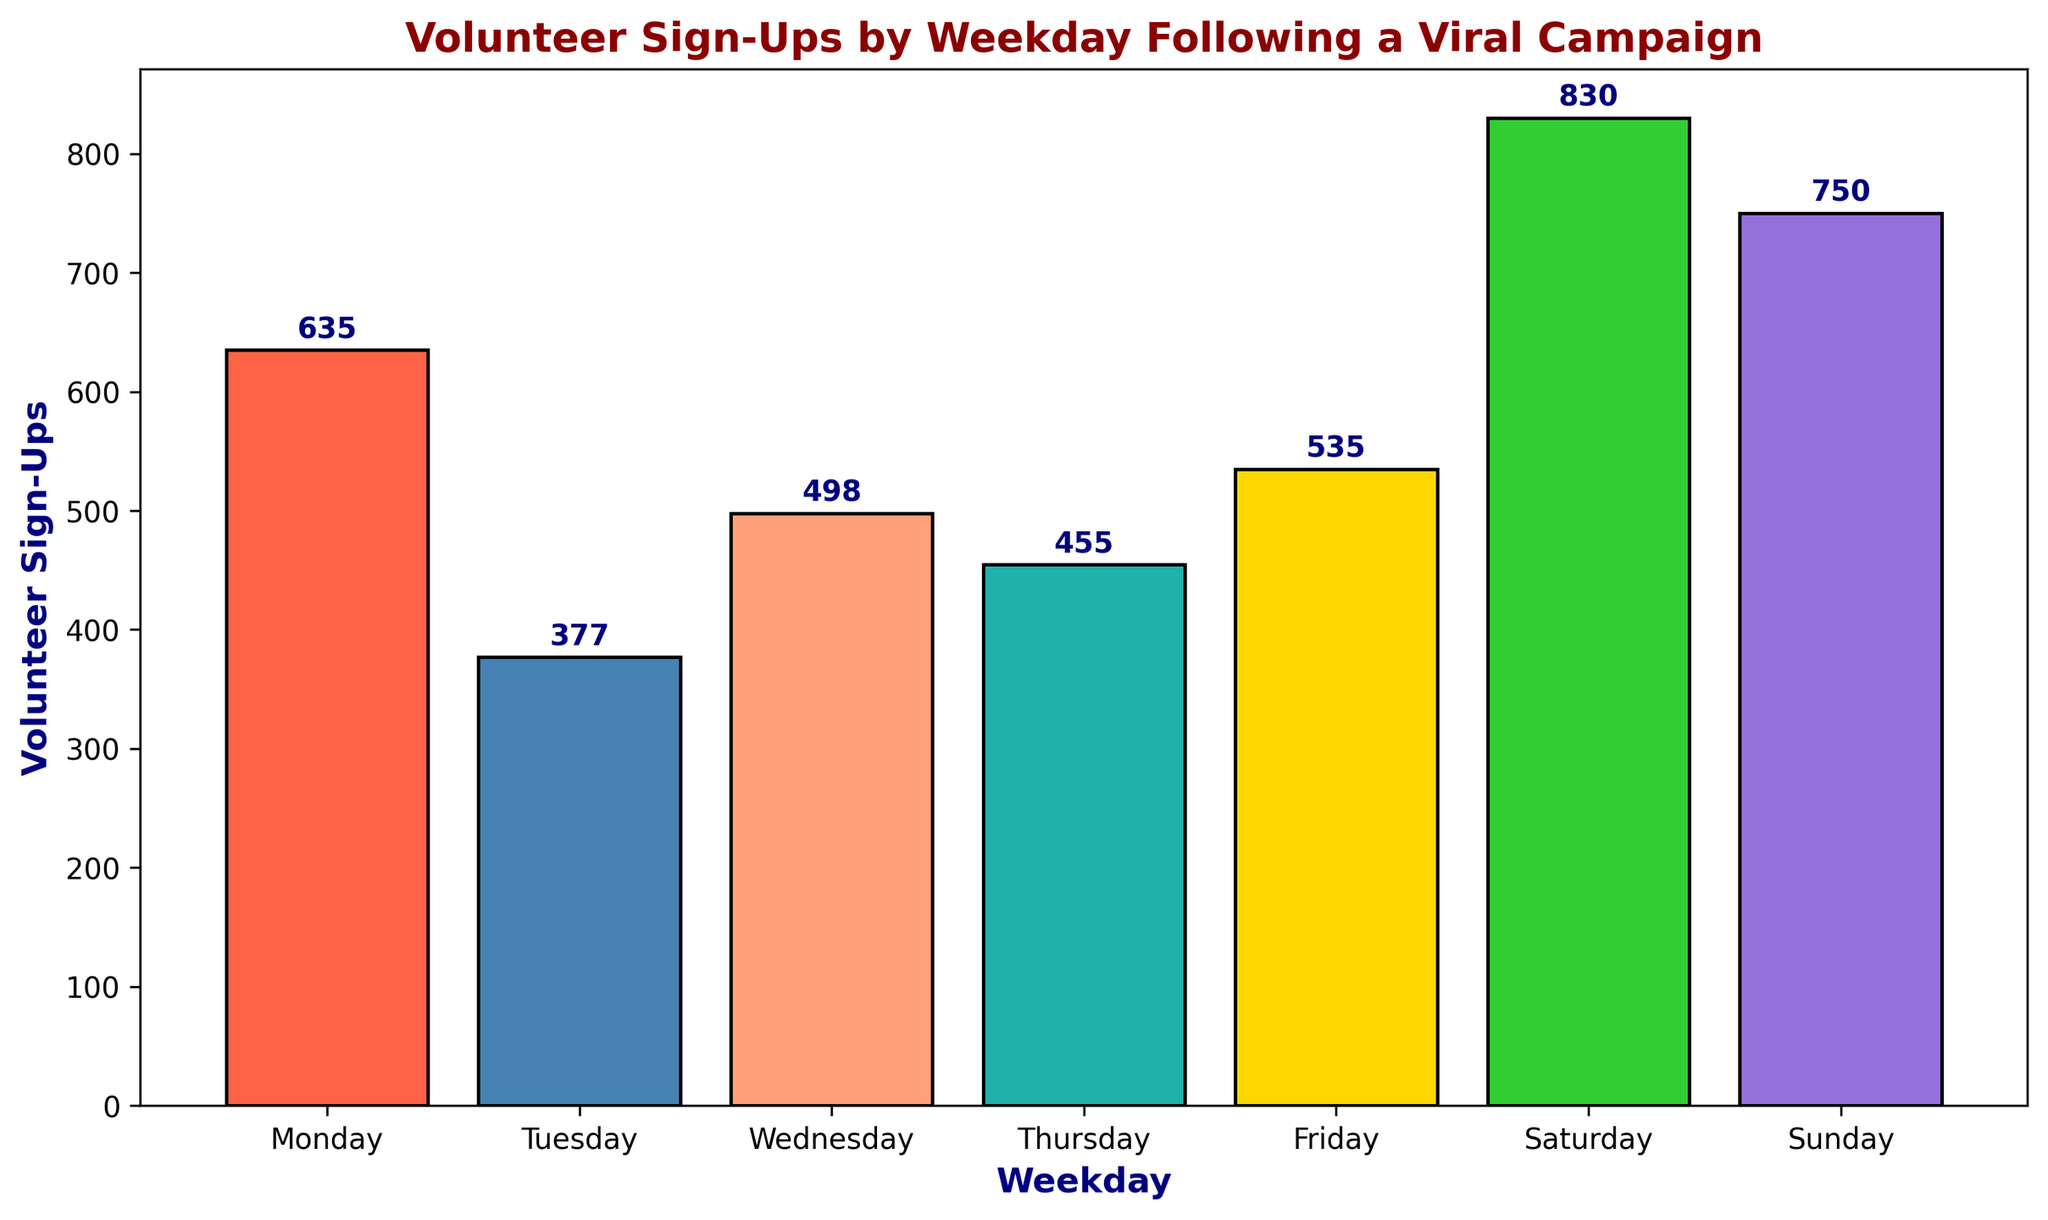What is the total number of volunteer sign-ups on Saturdays? Sum the heights of the bars for Saturdays. There are four Saturdays with sign-up counts: 200, 210, 205, and 215. Adding these together: 200 + 210 + 205 + 215 = 830.
Answer: 830 Which weekday has the highest number of volunteer sign-ups? Identify the tallest bar in the chart. The highest bar corresponds to Saturday with 830 sign-ups.
Answer: Saturday How many more volunteer sign-ups were there on Sunday compared to Tuesday? Find the heights of the bars for both weekdays. Sum them: Sunday has 180+185+190+195 = 750 and Tuesday has 90+95+92+100 = 377. Subtract: 750 - 377 = 373.
Answer: 373 What is the second least popular day for volunteer sign-ups? Order the total sign-ups for each day from least to most. Tuesday has the least sign-ups, followed by Thursday with 455 sign-ups.
Answer: Thursday Which weekday has the smallest range of volunteer sign-ups? Look at the spread of sign-ups on each day. Monday ranges from 150 to 170 (range of 20), Tuesday from 90 to 100 (range of 10), and so on. The smallest range is for Tuesday.
Answer: Tuesday Comparing Friday and Thursday, which day has a higher total number of sign-ups? Sum the heights of the bars for both days. For Friday: 130+135+132+138 = 535; for Thursday: 110+115+112+118 = 455. Friday has higher numbers.
Answer: Friday Calculate the average number of sign-ups on Wednesdays. Sum the values for Wednesday and divide by the number of occurrences. Values: 120, 125, 123, 130. Therefore, (120+125+123+130)/4 = 498/4 = 124.5.
Answer: 124.5 What is the difference in sign-ups between the highest and lowest days? Identify the maximum (Saturday with 830) and minimum (Tuesday with 377). Calculate the difference: 830 - 377 = 453.
Answer: 453 What are the total sign-ups for weekdays (Monday to Friday) combined? Sum the total sign-ups for Monday, Tuesday, Wednesday, Thursday, and Friday. Counts are 635 (Monday) + 377 (Tuesday) + 498 (Wednesday) + 455 (Thursday) + 535 (Friday). Total: 2500.
Answer: 2500 